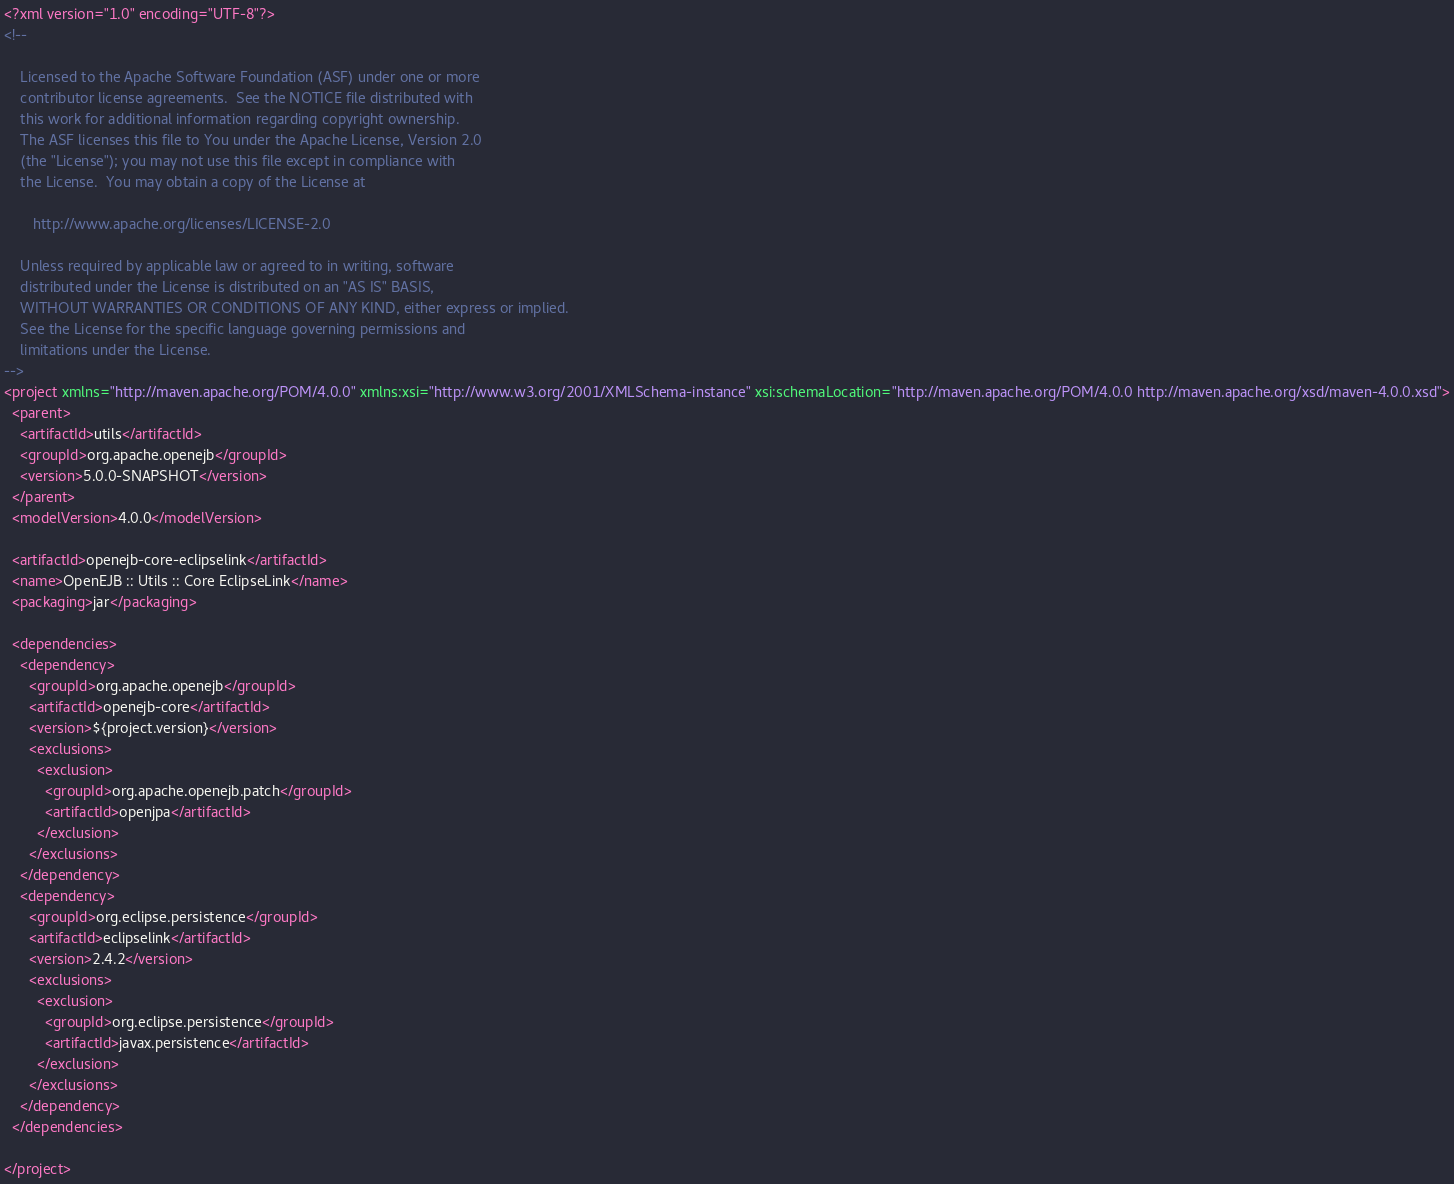<code> <loc_0><loc_0><loc_500><loc_500><_XML_><?xml version="1.0" encoding="UTF-8"?>
<!--

    Licensed to the Apache Software Foundation (ASF) under one or more
    contributor license agreements.  See the NOTICE file distributed with
    this work for additional information regarding copyright ownership.
    The ASF licenses this file to You under the Apache License, Version 2.0
    (the "License"); you may not use this file except in compliance with
    the License.  You may obtain a copy of the License at

       http://www.apache.org/licenses/LICENSE-2.0

    Unless required by applicable law or agreed to in writing, software
    distributed under the License is distributed on an "AS IS" BASIS,
    WITHOUT WARRANTIES OR CONDITIONS OF ANY KIND, either express or implied.
    See the License for the specific language governing permissions and
    limitations under the License.
-->
<project xmlns="http://maven.apache.org/POM/4.0.0" xmlns:xsi="http://www.w3.org/2001/XMLSchema-instance" xsi:schemaLocation="http://maven.apache.org/POM/4.0.0 http://maven.apache.org/xsd/maven-4.0.0.xsd">
  <parent>
    <artifactId>utils</artifactId>
    <groupId>org.apache.openejb</groupId>
    <version>5.0.0-SNAPSHOT</version>
  </parent>
  <modelVersion>4.0.0</modelVersion>

  <artifactId>openejb-core-eclipselink</artifactId>
  <name>OpenEJB :: Utils :: Core EclipseLink</name>
  <packaging>jar</packaging>

  <dependencies>
    <dependency>
      <groupId>org.apache.openejb</groupId>
      <artifactId>openejb-core</artifactId>
      <version>${project.version}</version>
      <exclusions>
        <exclusion>
          <groupId>org.apache.openejb.patch</groupId>
          <artifactId>openjpa</artifactId>
        </exclusion>
      </exclusions>
    </dependency>
    <dependency>
      <groupId>org.eclipse.persistence</groupId>
      <artifactId>eclipselink</artifactId>
      <version>2.4.2</version>
      <exclusions>
        <exclusion>
          <groupId>org.eclipse.persistence</groupId>
          <artifactId>javax.persistence</artifactId>
        </exclusion>
      </exclusions>
    </dependency>
  </dependencies>

</project>
</code> 